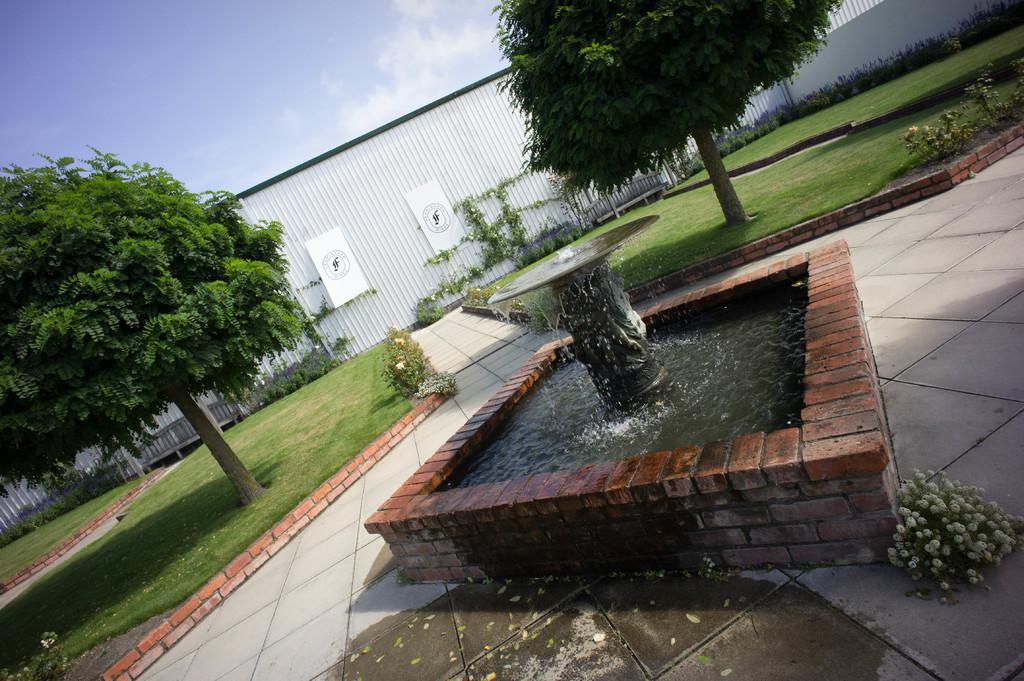Can you describe this image briefly? In the image I can see the white boards with design on it and they are on the shutter. Here I can see trees, grass, brick wall, water fountain and flower plants. Here I can see footpath and the sky. 